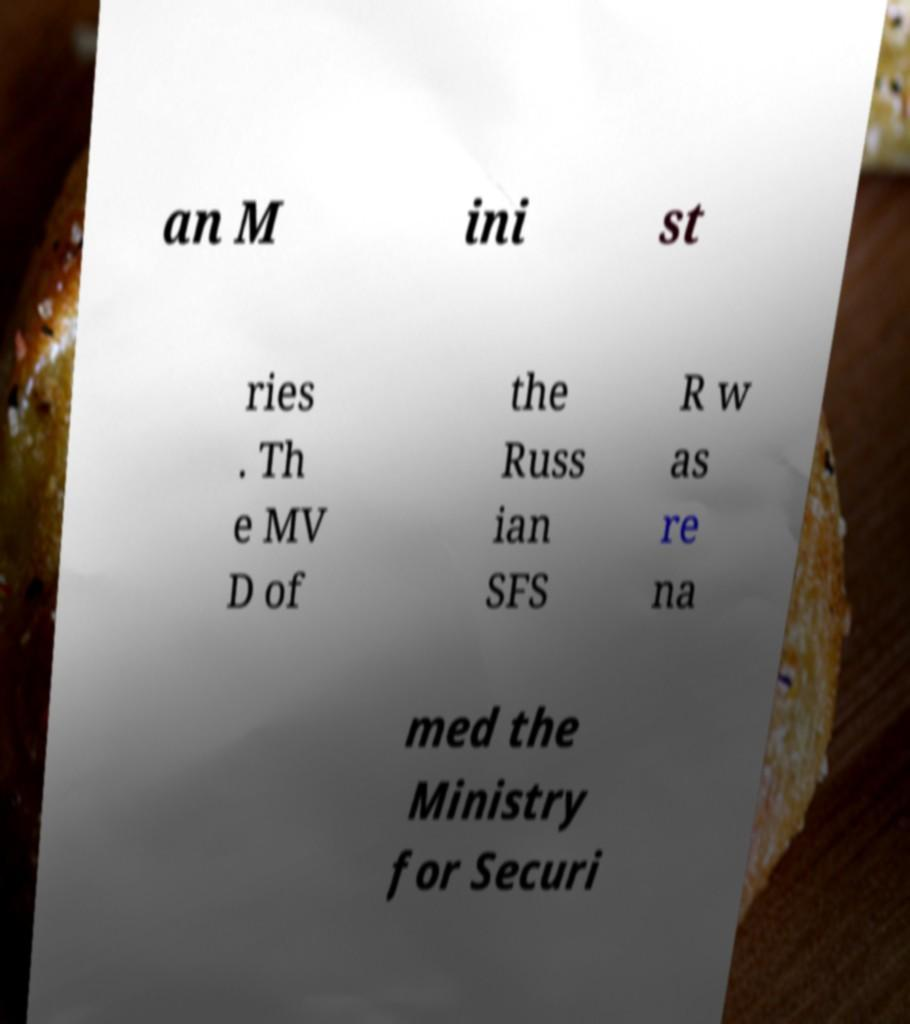Could you assist in decoding the text presented in this image and type it out clearly? an M ini st ries . Th e MV D of the Russ ian SFS R w as re na med the Ministry for Securi 